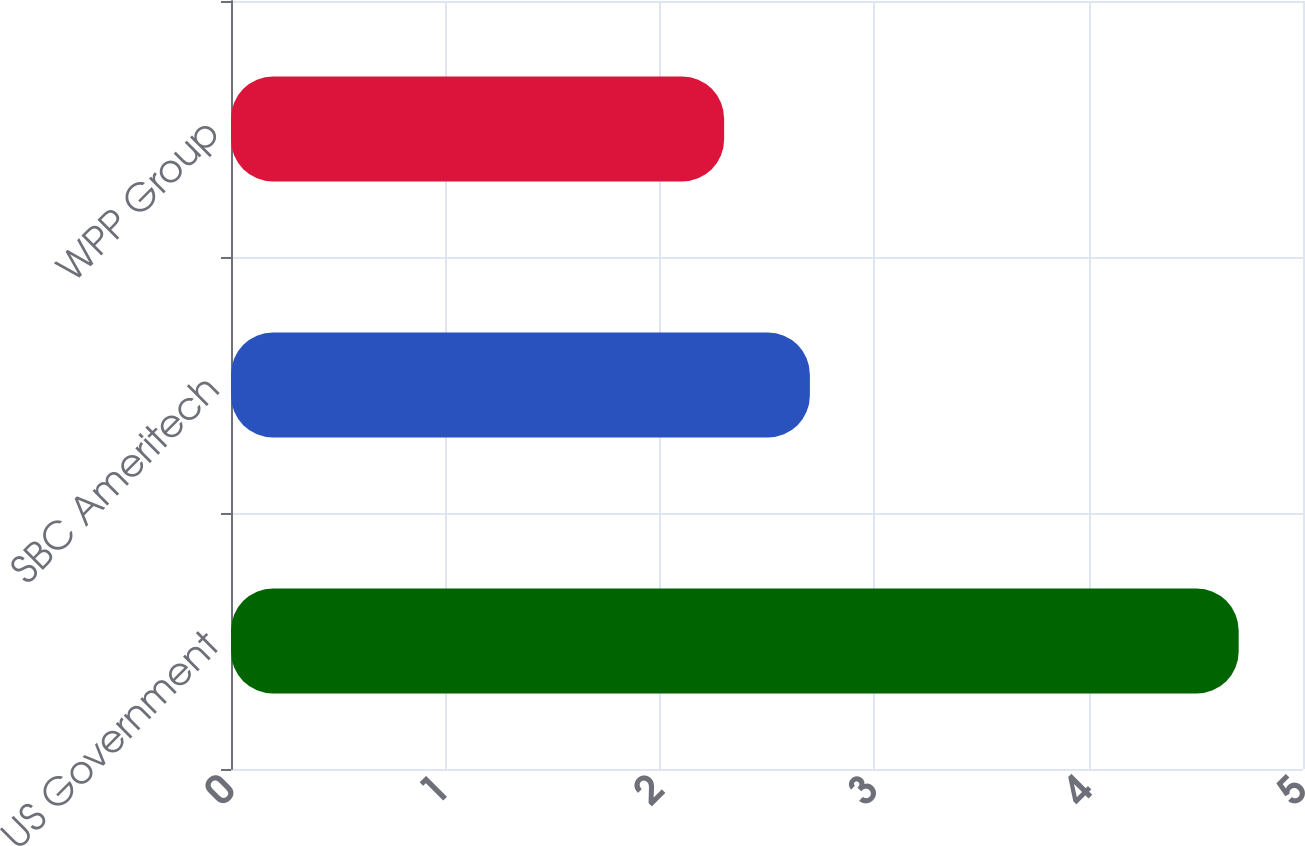Convert chart to OTSL. <chart><loc_0><loc_0><loc_500><loc_500><bar_chart><fcel>US Government<fcel>SBC Ameritech<fcel>WPP Group<nl><fcel>4.7<fcel>2.7<fcel>2.3<nl></chart> 